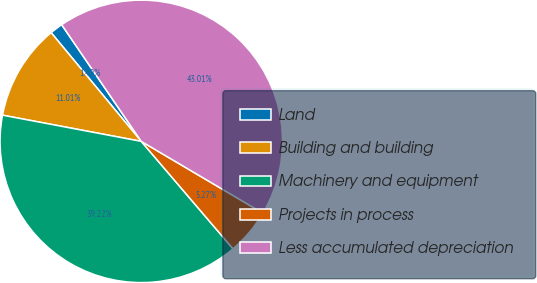Convert chart to OTSL. <chart><loc_0><loc_0><loc_500><loc_500><pie_chart><fcel>Land<fcel>Building and building<fcel>Machinery and equipment<fcel>Projects in process<fcel>Less accumulated depreciation<nl><fcel>1.49%<fcel>11.01%<fcel>39.22%<fcel>5.27%<fcel>43.01%<nl></chart> 